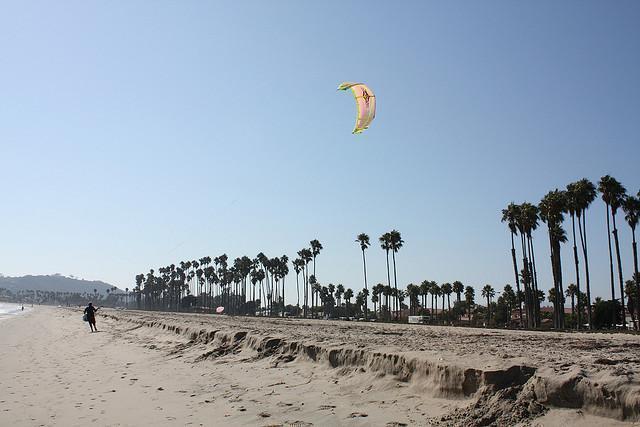What sport can be associated with the above picture?
Choose the right answer from the provided options to respond to the question.
Options: Wake boarding, paragliding, surfing, sailing. Paragliding. 